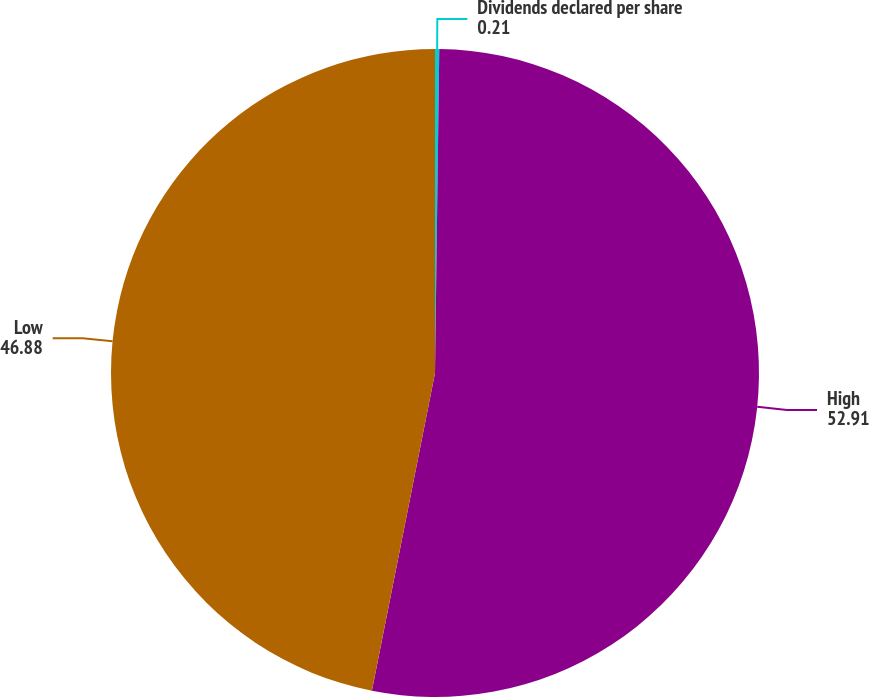<chart> <loc_0><loc_0><loc_500><loc_500><pie_chart><fcel>Dividends declared per share<fcel>High<fcel>Low<nl><fcel>0.21%<fcel>52.91%<fcel>46.88%<nl></chart> 